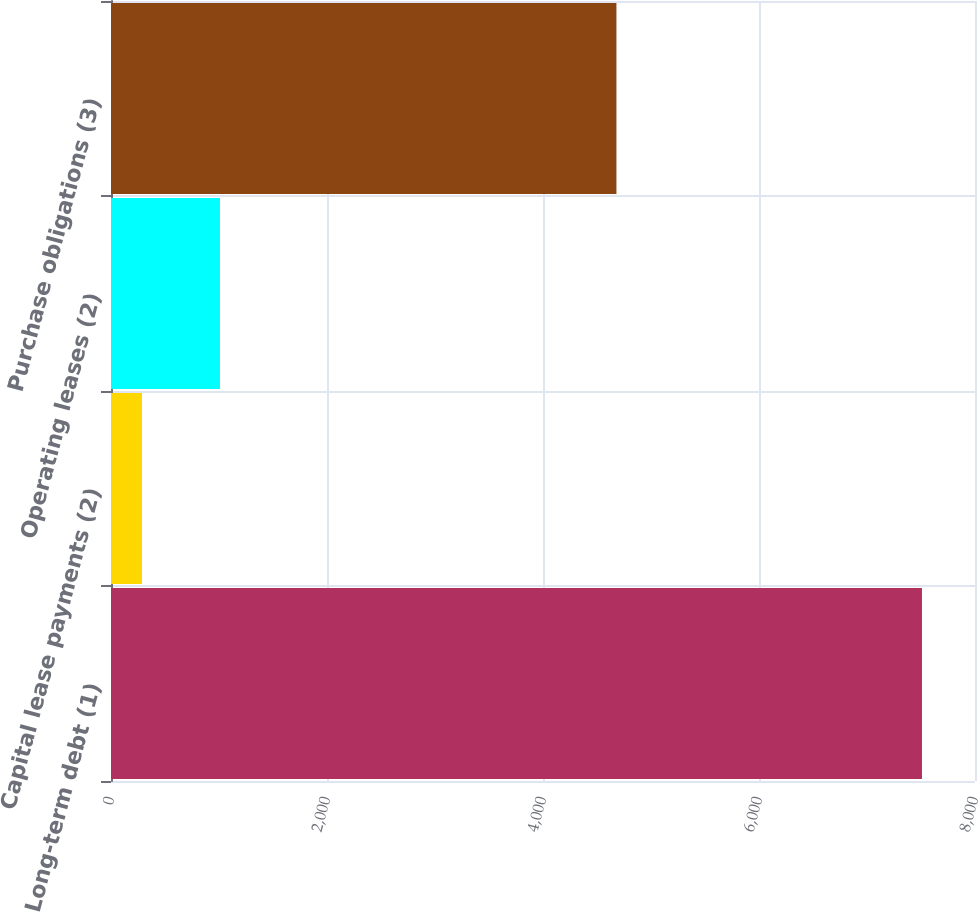<chart> <loc_0><loc_0><loc_500><loc_500><bar_chart><fcel>Long-term debt (1)<fcel>Capital lease payments (2)<fcel>Operating leases (2)<fcel>Purchase obligations (3)<nl><fcel>7509<fcel>287<fcel>1009.2<fcel>4680<nl></chart> 